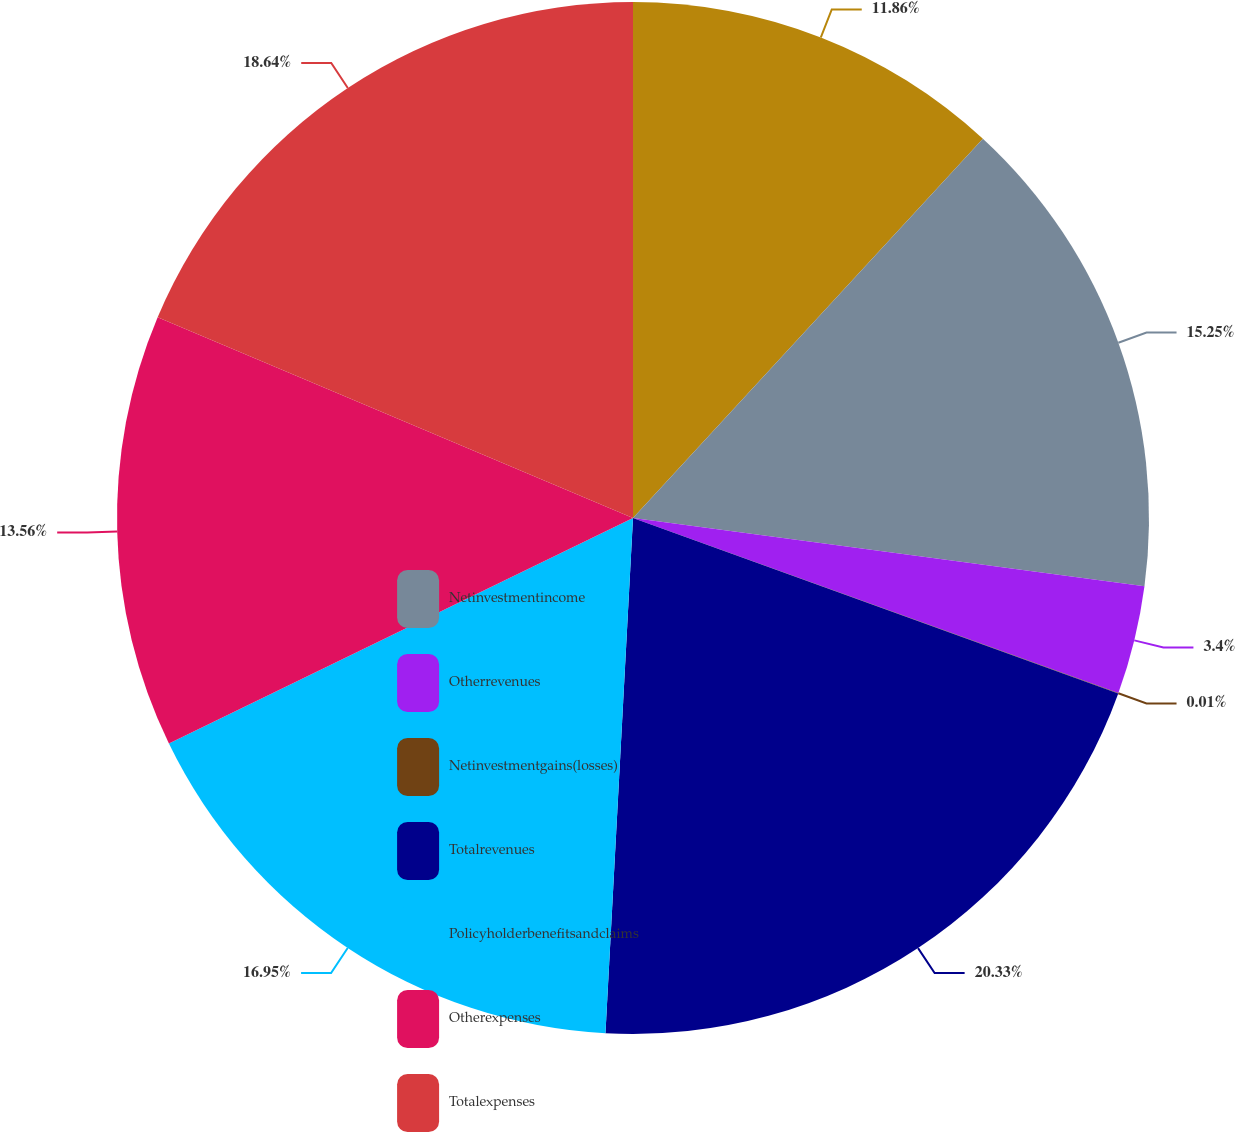<chart> <loc_0><loc_0><loc_500><loc_500><pie_chart><ecel><fcel>Netinvestmentincome<fcel>Otherrevenues<fcel>Netinvestmentgains(losses)<fcel>Totalrevenues<fcel>Policyholderbenefitsandclaims<fcel>Otherexpenses<fcel>Totalexpenses<nl><fcel>11.86%<fcel>15.25%<fcel>3.4%<fcel>0.01%<fcel>20.33%<fcel>16.95%<fcel>13.56%<fcel>18.64%<nl></chart> 